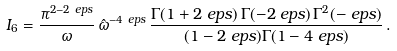<formula> <loc_0><loc_0><loc_500><loc_500>I _ { 6 } & = \frac { \pi ^ { 2 - 2 \ e p s } } { \omega } \, \hat { \omega } ^ { - 4 \ e p s } \, \frac { \Gamma ( 1 + 2 \ e p s ) \, \Gamma ( - 2 \ e p s ) \, \Gamma ^ { 2 } ( - \ e p s ) } { ( 1 - 2 \ e p s ) \Gamma ( 1 - 4 \ e p s ) } \, .</formula> 